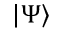Convert formula to latex. <formula><loc_0><loc_0><loc_500><loc_500>| \Psi \rangle</formula> 